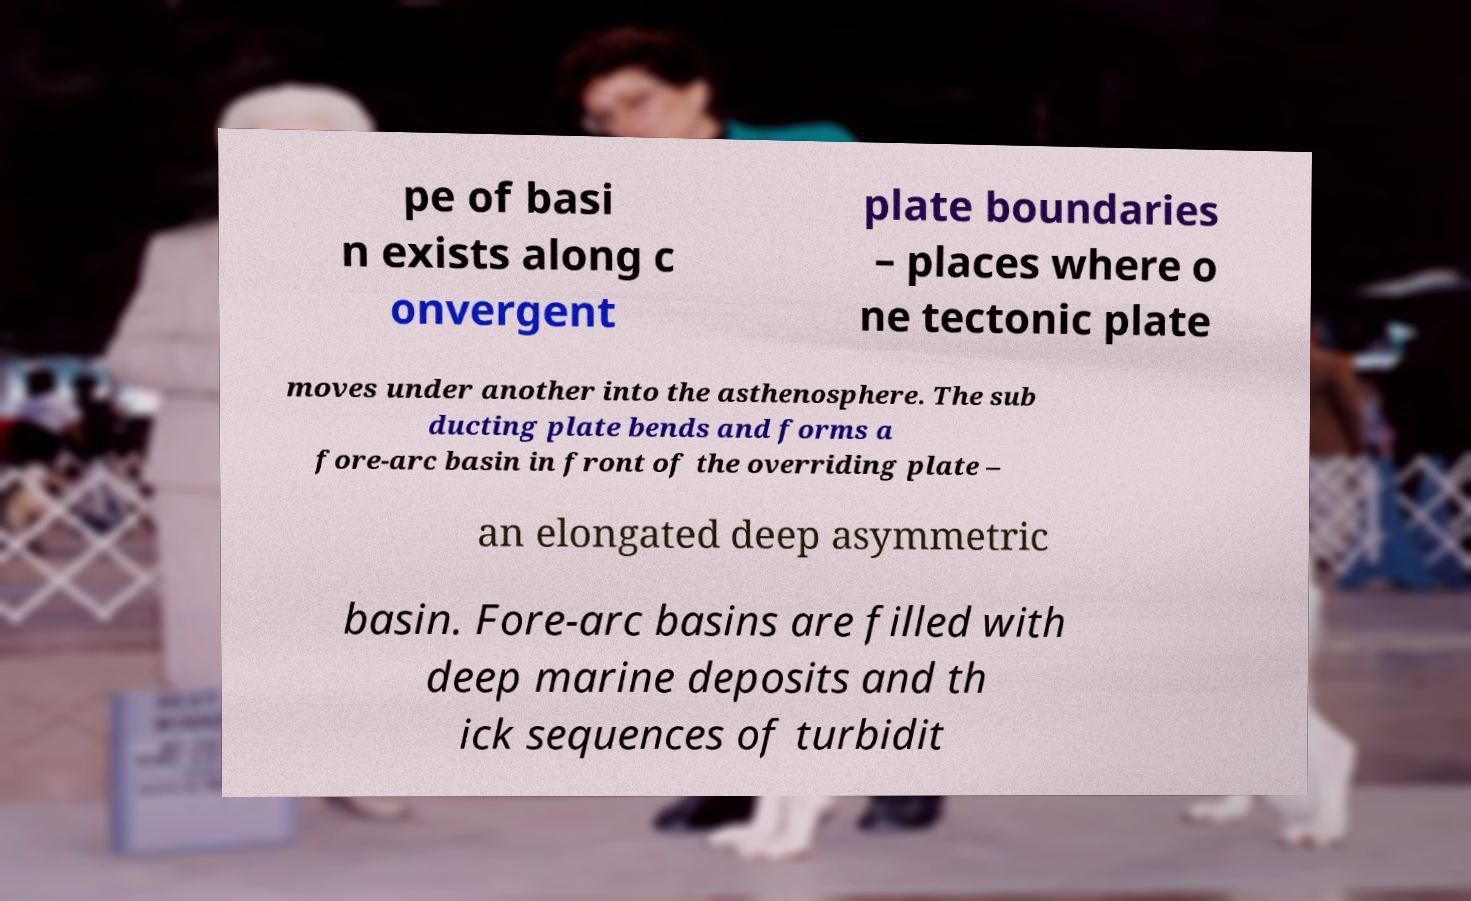Can you accurately transcribe the text from the provided image for me? pe of basi n exists along c onvergent plate boundaries – places where o ne tectonic plate moves under another into the asthenosphere. The sub ducting plate bends and forms a fore-arc basin in front of the overriding plate – an elongated deep asymmetric basin. Fore-arc basins are filled with deep marine deposits and th ick sequences of turbidit 